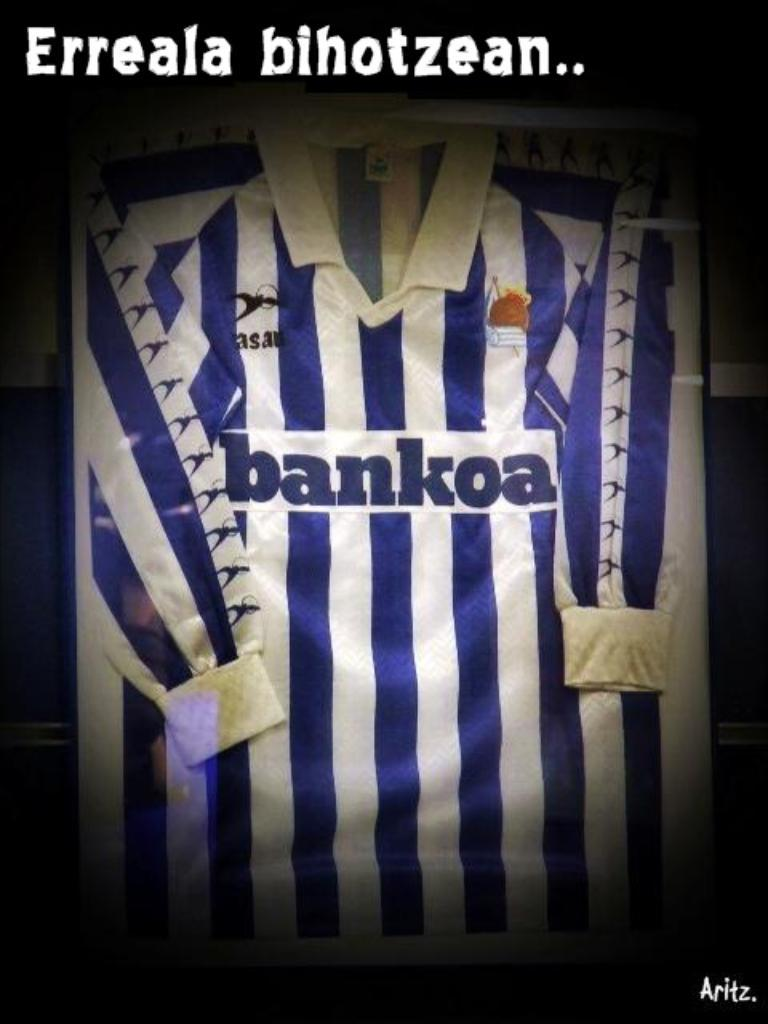<image>
Provide a brief description of the given image. A sports shirt with blue and white stripes that reads "bankoa." 